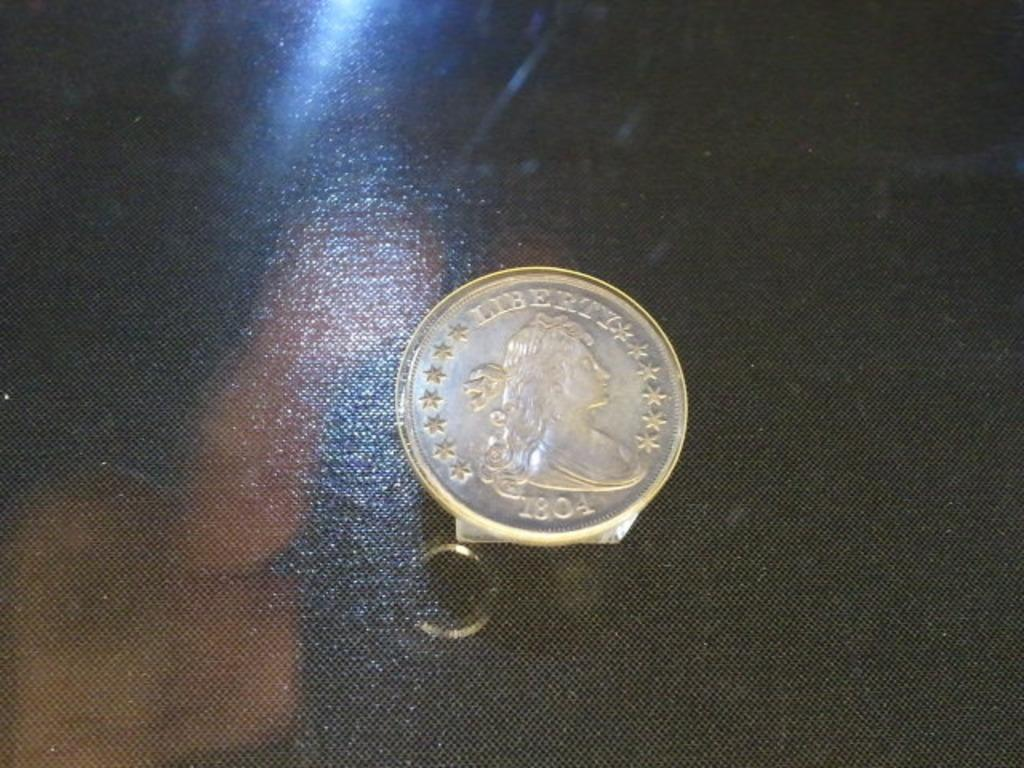<image>
Offer a succinct explanation of the picture presented. Liberty, 1804 is etched into the face of this coin. 